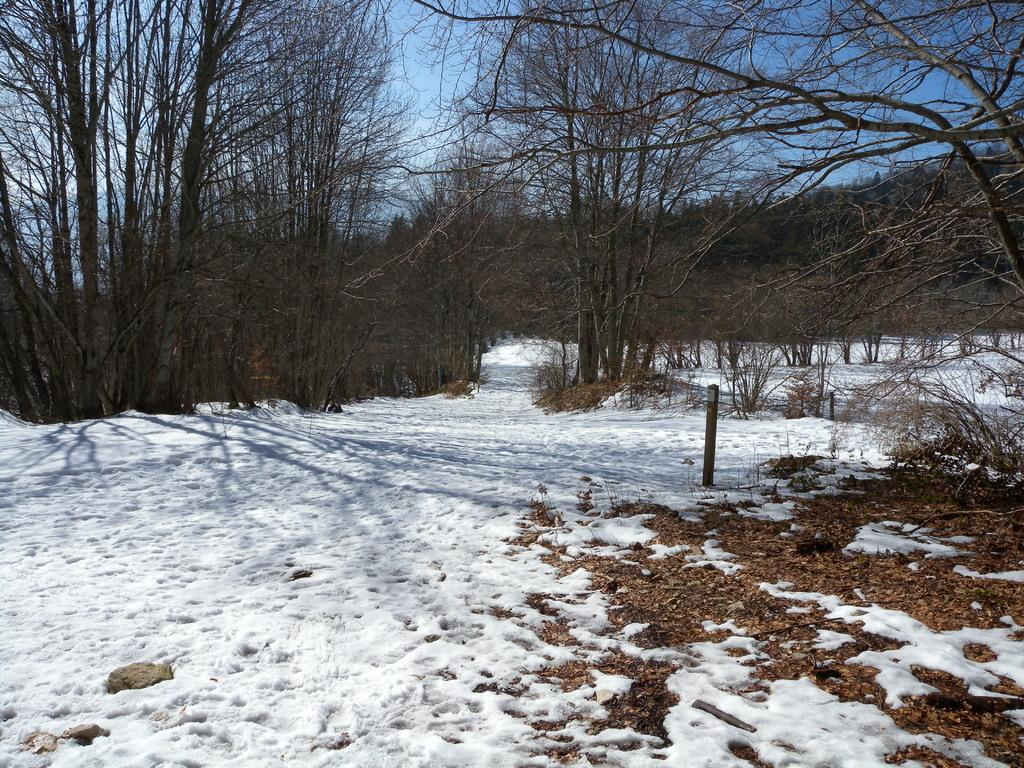What is located in the foreground of the image? There is ice and a pole in the foreground of the image. What can be seen in the background of the image? There are trees in the background of the image. What is visible at the top of the image? The sky is visible at the top of the image. When was the image taken? The image was taken during the day. Where was the image taken? The image was taken near a mountain. What type of van can be seen parked near the trees in the image? There is no van present in the image; it only features ice, a pole, trees, and the sky. How many tomatoes are visible on the pole in the image? There are no tomatoes present in the image; the pole is not associated with any tomatoes. 